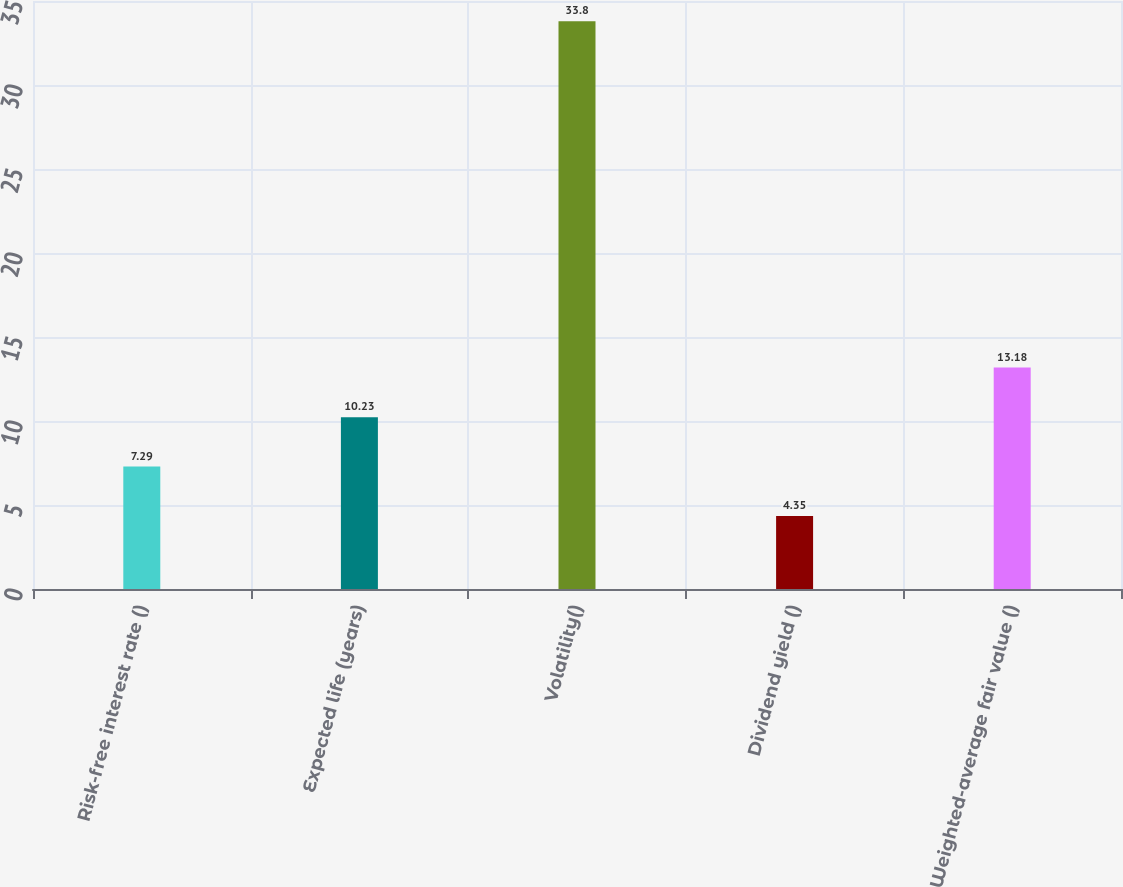Convert chart. <chart><loc_0><loc_0><loc_500><loc_500><bar_chart><fcel>Risk-free interest rate ()<fcel>Expected life (years)<fcel>Volatility()<fcel>Dividend yield ()<fcel>Weighted-average fair value ()<nl><fcel>7.29<fcel>10.23<fcel>33.8<fcel>4.35<fcel>13.18<nl></chart> 